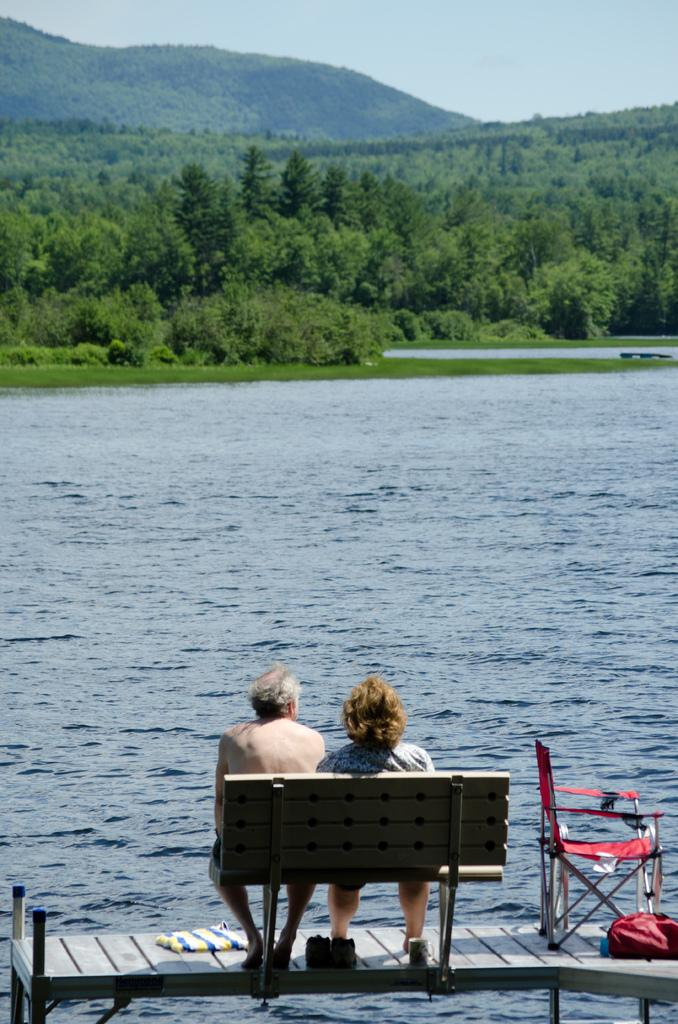Who can be seen in the image? There is a man and a woman in the image. Where are they sitting? They are sitting on a bench of a deck. What else is on the deck? There is a chair and a bag on the deck. What can be seen in the background of the image? There is water, trees, a hill, and the sky visible in the background. What type of root is growing through the deck in the image? There is no root growing through the deck in the image. What school is visible in the background of the image? There is no school visible in the background of the image. 